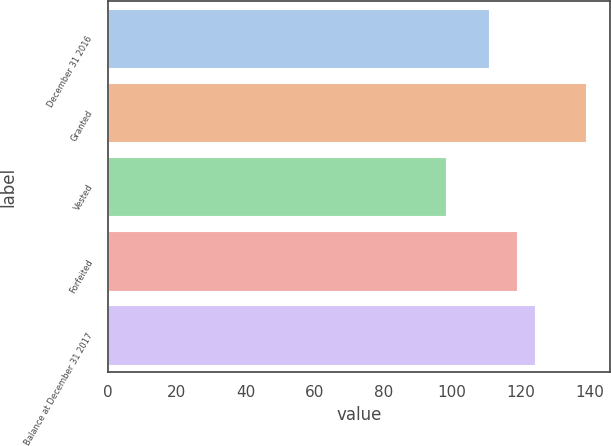Convert chart. <chart><loc_0><loc_0><loc_500><loc_500><bar_chart><fcel>December 31 2016<fcel>Granted<fcel>Vested<fcel>Forfeited<fcel>Balance at December 31 2017<nl><fcel>110.62<fcel>138.83<fcel>98.26<fcel>118.95<fcel>124.15<nl></chart> 